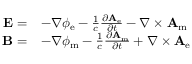<formula> <loc_0><loc_0><loc_500><loc_500>{ \begin{array} { r l } { E = } & { - \nabla \phi _ { e } - { \frac { 1 } { c } } { \frac { \partial A _ { e } } { \partial t } } - \nabla \times A _ { m } } \\ { B = } & { - \nabla \phi _ { m } - { \frac { 1 } { c } } { \frac { \partial A _ { m } } { \partial t } } + \nabla \times A _ { e } } \end{array} }</formula> 